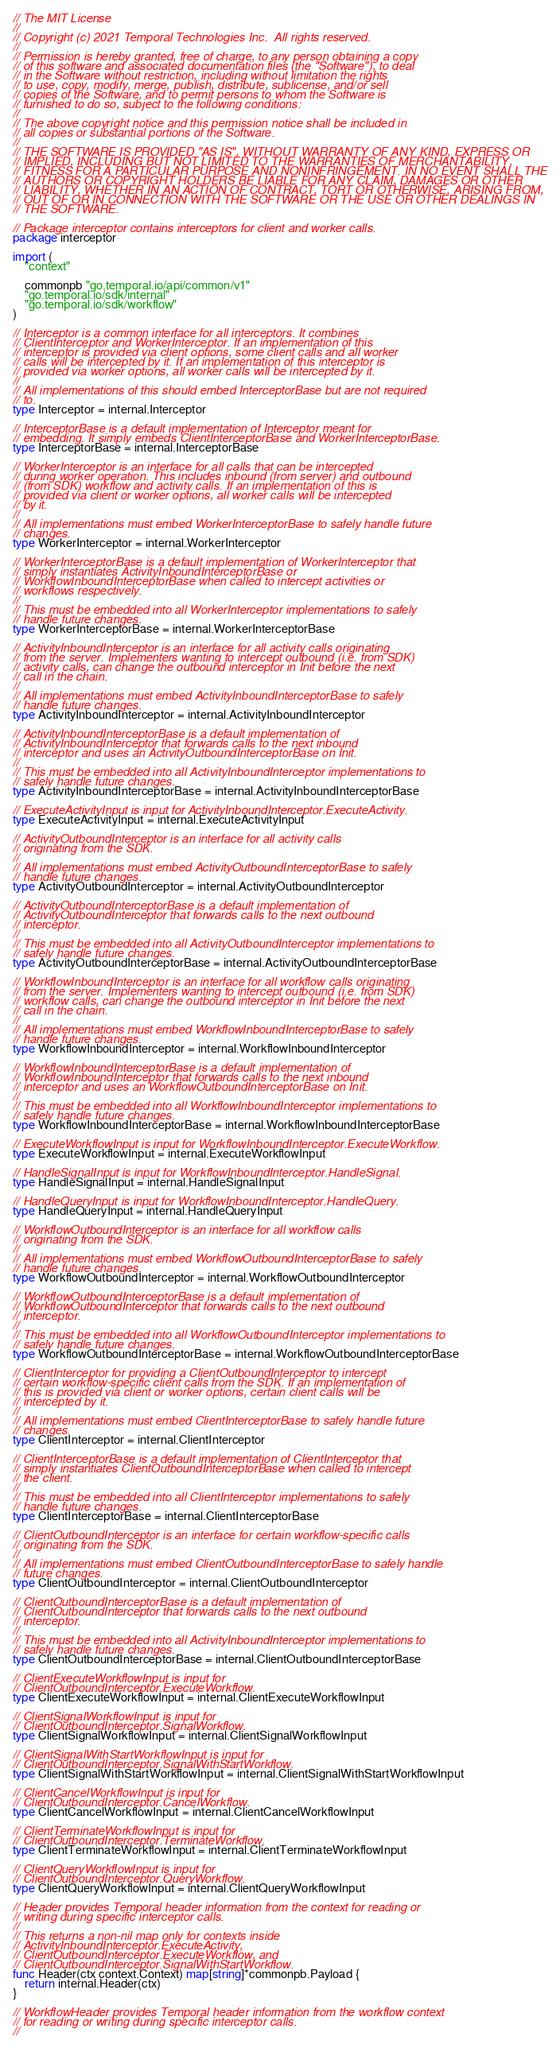<code> <loc_0><loc_0><loc_500><loc_500><_Go_>// The MIT License
//
// Copyright (c) 2021 Temporal Technologies Inc.  All rights reserved.
//
// Permission is hereby granted, free of charge, to any person obtaining a copy
// of this software and associated documentation files (the "Software"), to deal
// in the Software without restriction, including without limitation the rights
// to use, copy, modify, merge, publish, distribute, sublicense, and/or sell
// copies of the Software, and to permit persons to whom the Software is
// furnished to do so, subject to the following conditions:
//
// The above copyright notice and this permission notice shall be included in
// all copies or substantial portions of the Software.
//
// THE SOFTWARE IS PROVIDED "AS IS", WITHOUT WARRANTY OF ANY KIND, EXPRESS OR
// IMPLIED, INCLUDING BUT NOT LIMITED TO THE WARRANTIES OF MERCHANTABILITY,
// FITNESS FOR A PARTICULAR PURPOSE AND NONINFRINGEMENT. IN NO EVENT SHALL THE
// AUTHORS OR COPYRIGHT HOLDERS BE LIABLE FOR ANY CLAIM, DAMAGES OR OTHER
// LIABILITY, WHETHER IN AN ACTION OF CONTRACT, TORT OR OTHERWISE, ARISING FROM,
// OUT OF OR IN CONNECTION WITH THE SOFTWARE OR THE USE OR OTHER DEALINGS IN
// THE SOFTWARE.

// Package interceptor contains interceptors for client and worker calls.
package interceptor

import (
	"context"

	commonpb "go.temporal.io/api/common/v1"
	"go.temporal.io/sdk/internal"
	"go.temporal.io/sdk/workflow"
)

// Interceptor is a common interface for all interceptors. It combines
// ClientInterceptor and WorkerInterceptor. If an implementation of this
// interceptor is provided via client options, some client calls and all worker
// calls will be intercepted by it. If an implementation of this interceptor is
// provided via worker options, all worker calls will be intercepted by it.
//
// All implementations of this should embed InterceptorBase but are not required
// to.
type Interceptor = internal.Interceptor

// InterceptorBase is a default implementation of Interceptor meant for
// embedding. It simply embeds ClientInterceptorBase and WorkerInterceptorBase.
type InterceptorBase = internal.InterceptorBase

// WorkerInterceptor is an interface for all calls that can be intercepted
// during worker operation. This includes inbound (from server) and outbound
// (from SDK) workflow and activity calls. If an implementation of this is
// provided via client or worker options, all worker calls will be intercepted
// by it.
//
// All implementations must embed WorkerInterceptorBase to safely handle future
// changes.
type WorkerInterceptor = internal.WorkerInterceptor

// WorkerInterceptorBase is a default implementation of WorkerInterceptor that
// simply instantiates ActivityInboundInterceptorBase or
// WorkflowInboundInterceptorBase when called to intercept activities or
// workflows respectively.
//
// This must be embedded into all WorkerInterceptor implementations to safely
// handle future changes.
type WorkerInterceptorBase = internal.WorkerInterceptorBase

// ActivityInboundInterceptor is an interface for all activity calls originating
// from the server. Implementers wanting to intercept outbound (i.e. from SDK)
// activity calls, can change the outbound interceptor in Init before the next
// call in the chain.
//
// All implementations must embed ActivityInboundInterceptorBase to safely
// handle future changes.
type ActivityInboundInterceptor = internal.ActivityInboundInterceptor

// ActivityInboundInterceptorBase is a default implementation of
// ActivityInboundInterceptor that forwards calls to the next inbound
// interceptor and uses an ActivityOutboundInterceptorBase on Init.
//
// This must be embedded into all ActivityInboundInterceptor implementations to
// safely handle future changes.
type ActivityInboundInterceptorBase = internal.ActivityInboundInterceptorBase

// ExecuteActivityInput is input for ActivityInboundInterceptor.ExecuteActivity.
type ExecuteActivityInput = internal.ExecuteActivityInput

// ActivityOutboundInterceptor is an interface for all activity calls
// originating from the SDK.
//
// All implementations must embed ActivityOutboundInterceptorBase to safely
// handle future changes.
type ActivityOutboundInterceptor = internal.ActivityOutboundInterceptor

// ActivityOutboundInterceptorBase is a default implementation of
// ActivityOutboundInterceptor that forwards calls to the next outbound
// interceptor.
//
// This must be embedded into all ActivityOutboundInterceptor implementations to
// safely handle future changes.
type ActivityOutboundInterceptorBase = internal.ActivityOutboundInterceptorBase

// WorkflowInboundInterceptor is an interface for all workflow calls originating
// from the server. Implementers wanting to intercept outbound (i.e. from SDK)
// workflow calls, can change the outbound interceptor in Init before the next
// call in the chain.
//
// All implementations must embed WorkflowInboundInterceptorBase to safely
// handle future changes.
type WorkflowInboundInterceptor = internal.WorkflowInboundInterceptor

// WorkflowInboundInterceptorBase is a default implementation of
// WorkflowInboundInterceptor that forwards calls to the next inbound
// interceptor and uses an WorkflowOutboundInterceptorBase on Init.
//
// This must be embedded into all WorkflowInboundInterceptor implementations to
// safely handle future changes.
type WorkflowInboundInterceptorBase = internal.WorkflowInboundInterceptorBase

// ExecuteWorkflowInput is input for WorkflowInboundInterceptor.ExecuteWorkflow.
type ExecuteWorkflowInput = internal.ExecuteWorkflowInput

// HandleSignalInput is input for WorkflowInboundInterceptor.HandleSignal.
type HandleSignalInput = internal.HandleSignalInput

// HandleQueryInput is input for WorkflowInboundInterceptor.HandleQuery.
type HandleQueryInput = internal.HandleQueryInput

// WorkflowOutboundInterceptor is an interface for all workflow calls
// originating from the SDK.
//
// All implementations must embed WorkflowOutboundInterceptorBase to safely
// handle future changes.
type WorkflowOutboundInterceptor = internal.WorkflowOutboundInterceptor

// WorkflowOutboundInterceptorBase is a default implementation of
// WorkflowOutboundInterceptor that forwards calls to the next outbound
// interceptor.
//
// This must be embedded into all WorkflowOutboundInterceptor implementations to
// safely handle future changes.
type WorkflowOutboundInterceptorBase = internal.WorkflowOutboundInterceptorBase

// ClientInterceptor for providing a ClientOutboundInterceptor to intercept
// certain workflow-specific client calls from the SDK. If an implementation of
// this is provided via client or worker options, certain client calls will be
// intercepted by it.
//
// All implementations must embed ClientInterceptorBase to safely handle future
// changes.
type ClientInterceptor = internal.ClientInterceptor

// ClientInterceptorBase is a default implementation of ClientInterceptor that
// simply instantiates ClientOutboundInterceptorBase when called to intercept
// the client.
//
// This must be embedded into all ClientInterceptor implementations to safely
// handle future changes.
type ClientInterceptorBase = internal.ClientInterceptorBase

// ClientOutboundInterceptor is an interface for certain workflow-specific calls
// originating from the SDK.
//
// All implementations must embed ClientOutboundInterceptorBase to safely handle
// future changes.
type ClientOutboundInterceptor = internal.ClientOutboundInterceptor

// ClientOutboundInterceptorBase is a default implementation of
// ClientOutboundInterceptor that forwards calls to the next outbound
// interceptor.
//
// This must be embedded into all ActivityInboundInterceptor implementations to
// safely handle future changes.
type ClientOutboundInterceptorBase = internal.ClientOutboundInterceptorBase

// ClientExecuteWorkflowInput is input for
// ClientOutboundInterceptor.ExecuteWorkflow.
type ClientExecuteWorkflowInput = internal.ClientExecuteWorkflowInput

// ClientSignalWorkflowInput is input for
// ClientOutboundInterceptor.SignalWorkflow.
type ClientSignalWorkflowInput = internal.ClientSignalWorkflowInput

// ClientSignalWithStartWorkflowInput is input for
// ClientOutboundInterceptor.SignalWithStartWorkflow.
type ClientSignalWithStartWorkflowInput = internal.ClientSignalWithStartWorkflowInput

// ClientCancelWorkflowInput is input for
// ClientOutboundInterceptor.CancelWorkflow.
type ClientCancelWorkflowInput = internal.ClientCancelWorkflowInput

// ClientTerminateWorkflowInput is input for
// ClientOutboundInterceptor.TerminateWorkflow.
type ClientTerminateWorkflowInput = internal.ClientTerminateWorkflowInput

// ClientQueryWorkflowInput is input for
// ClientOutboundInterceptor.QueryWorkflow.
type ClientQueryWorkflowInput = internal.ClientQueryWorkflowInput

// Header provides Temporal header information from the context for reading or
// writing during specific interceptor calls.
//
// This returns a non-nil map only for contexts inside
// ActivityInboundInterceptor.ExecuteActivity,
// ClientOutboundInterceptor.ExecuteWorkflow, and
// ClientOutboundInterceptor.SignalWithStartWorkflow.
func Header(ctx context.Context) map[string]*commonpb.Payload {
	return internal.Header(ctx)
}

// WorkflowHeader provides Temporal header information from the workflow context
// for reading or writing during specific interceptor calls.
//</code> 